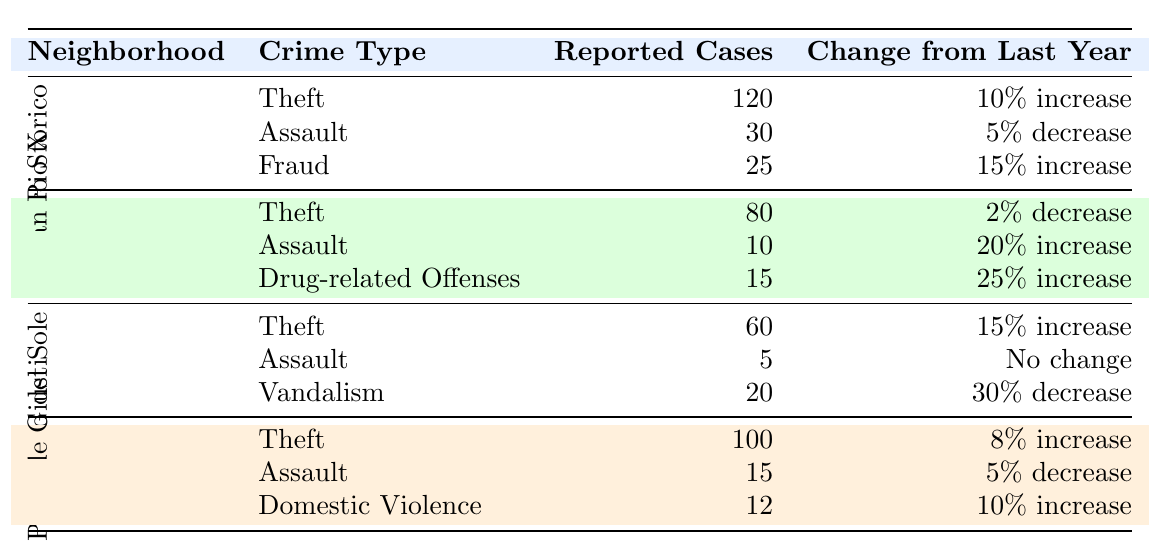What is the total number of reported theft cases in Vicenza? To find the total number of reported theft cases, we sum the theft cases from all neighborhoods: 120 (Centro Storico) + 80 (San Pio X) + 60 (Villaggio del Sole) + 100 (Piazzale Giusti) = 360.
Answer: 360 Which neighborhood experienced the highest number of reported assault cases? Looking at the assault reported cases: Centro Storico has 30, San Pio X has 10, Villaggio del Sole has 5, and Piazzale Giusti has 15. The highest is 30 in Centro Storico.
Answer: Centro Storico Did drug-related offenses increase in San Pio X compared to last year? According to the table, drug-related offenses in San Pio X had 15 reported cases with a "25% increase" from the previous year, indicating an increase.
Answer: Yes What is the change from last year in reported cases of vandalism in Villaggio del Sole? The table states that vandalism in Villaggio del Sole had 20 reported cases with a "30% decrease" from last year, indicating a reduction in incidents.
Answer: 30% decrease What is the total change in reported cases of theft across all neighborhoods? The changes in theft cases are as follows: Centro Storico had a 10% increase, San Pio X had a 2% decrease, Villaggio del Sole had a 15% increase, and Piazzale Giusti had an 8% increase. The net change is calculated as: (10 - 2 + 15 + 8) = 31% total increase.
Answer: 31% increase Which neighborhood has the least significant change in assault cases? Reviewing the changes in assault cases: Centro Storico had a 5% decrease, San Pio X had a 20% increase, Villaggio del Sole had no change, and Piazzale Giusti had a 5% decrease. Villaggio del Sole had no change, making it the least significant.
Answer: Villaggio del Sole 